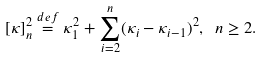<formula> <loc_0><loc_0><loc_500><loc_500>[ \kappa ] _ { n } ^ { 2 } \stackrel { d e f } { = } \kappa _ { 1 } ^ { 2 } + \sum _ { i = 2 } ^ { n } ( \kappa _ { i } - \kappa _ { i - 1 } ) ^ { 2 } , \ n \geq 2 .</formula> 